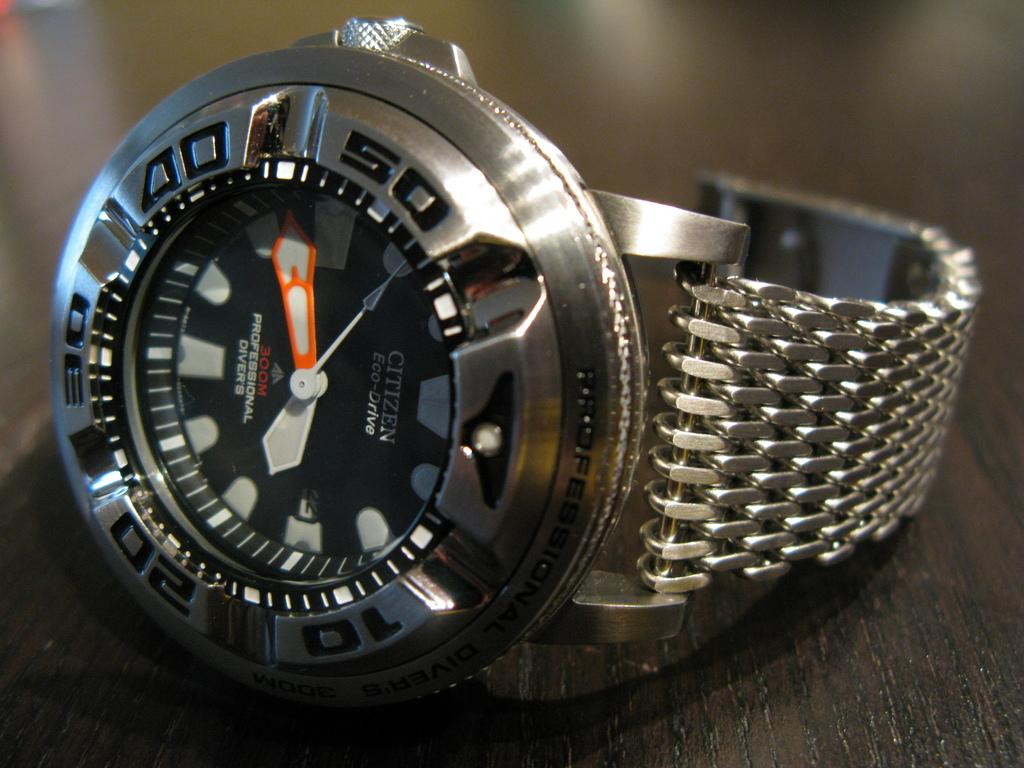<image>
Give a short and clear explanation of the subsequent image. A chrome and black Citizen watch is on a table. 